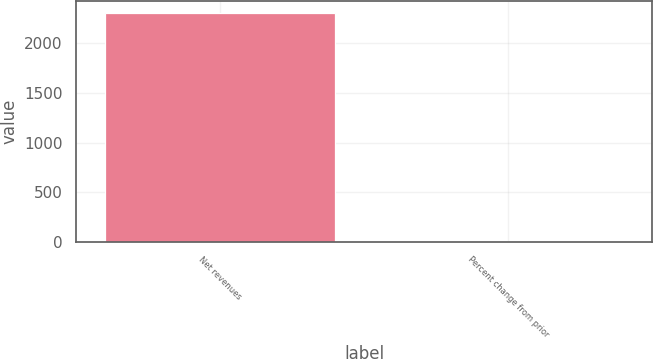Convert chart to OTSL. <chart><loc_0><loc_0><loc_500><loc_500><bar_chart><fcel>Net revenues<fcel>Percent change from prior<nl><fcel>2309<fcel>4<nl></chart> 